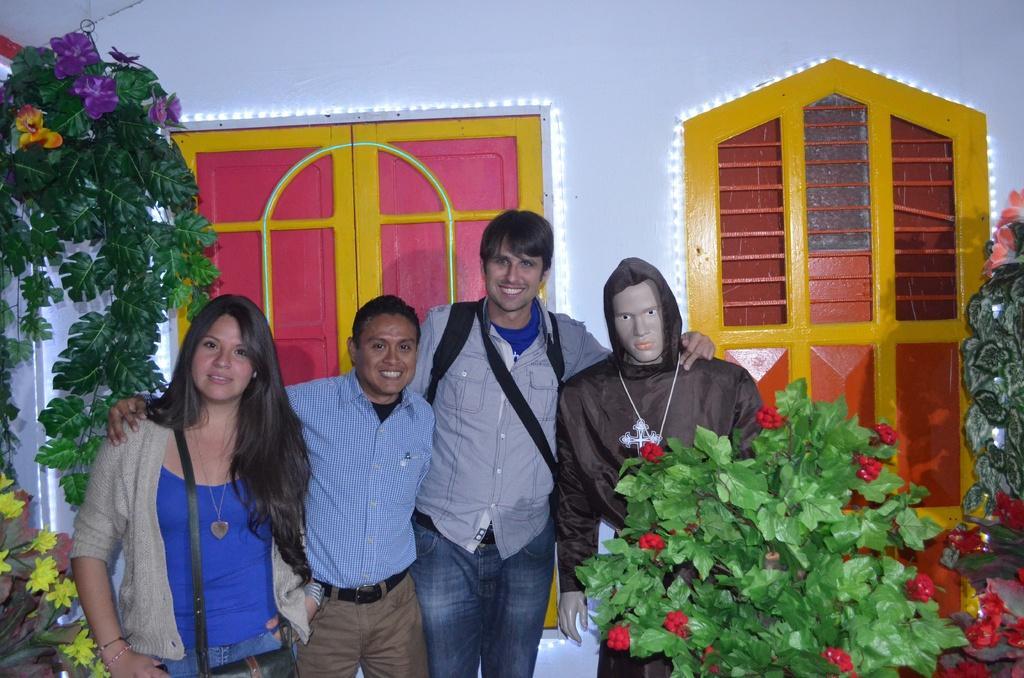How would you summarize this image in a sentence or two? In this picture I can see three persons are standing in the middle, on the right side there is a doll. There are plants on either side of this image, in the background I can see the windows decorated with the lights. 